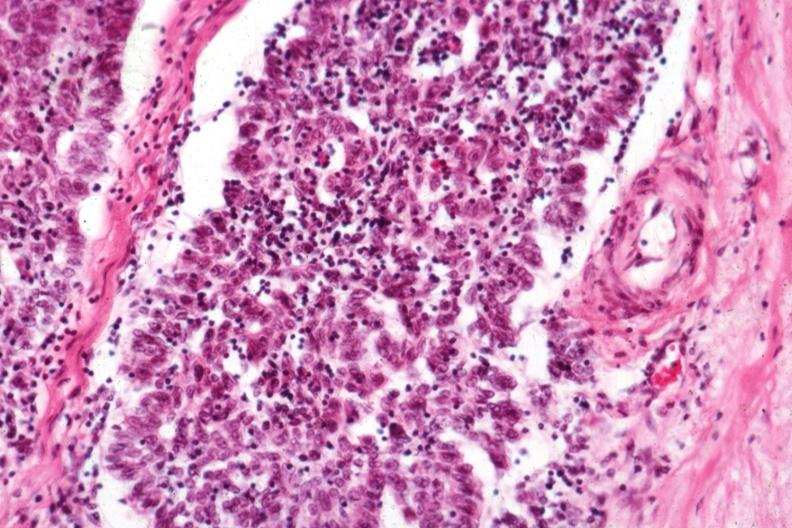s miliary tuberculosis present?
Answer the question using a single word or phrase. No 